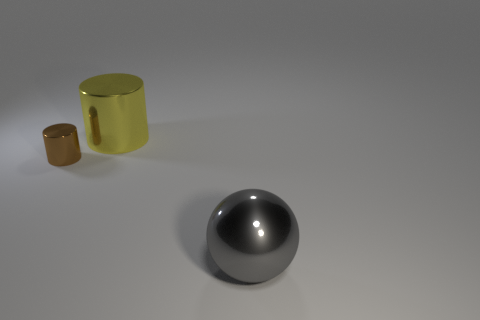Add 1 cyan blocks. How many objects exist? 4 Subtract all cylinders. How many objects are left? 1 Subtract all yellow cylinders. Subtract all brown metallic objects. How many objects are left? 1 Add 1 big yellow cylinders. How many big yellow cylinders are left? 2 Add 3 large metallic cylinders. How many large metallic cylinders exist? 4 Subtract 0 green cubes. How many objects are left? 3 